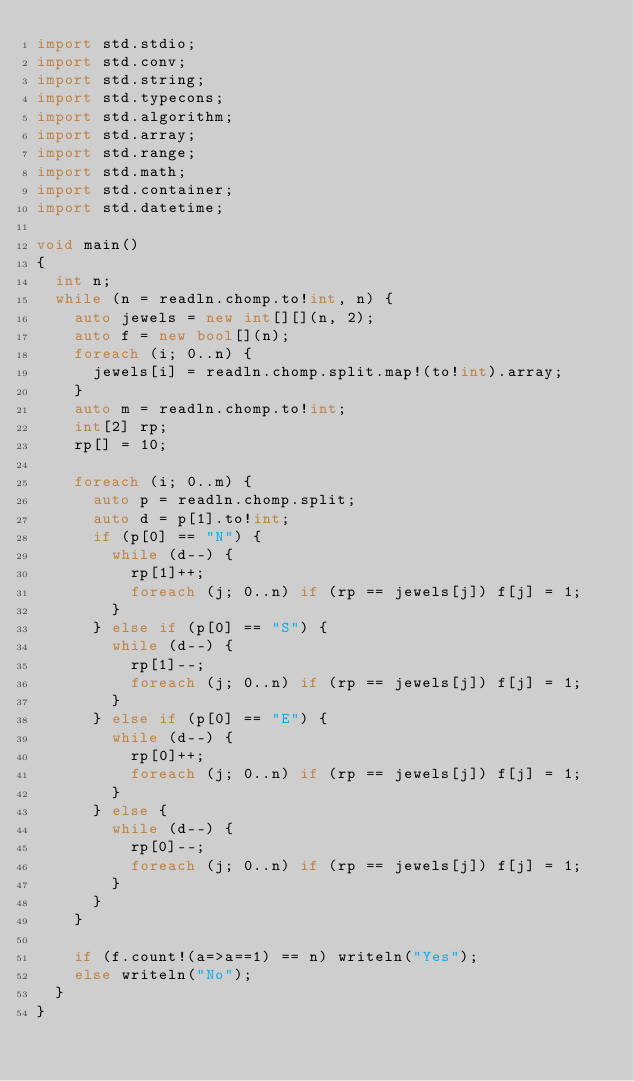<code> <loc_0><loc_0><loc_500><loc_500><_D_>import std.stdio;
import std.conv;
import std.string;
import std.typecons;
import std.algorithm;
import std.array;
import std.range;
import std.math;
import std.container;
import std.datetime;

void main()
{
	int n;
	while (n = readln.chomp.to!int, n) {
		auto jewels = new int[][](n, 2);
		auto f = new bool[](n);
		foreach (i; 0..n) {
			jewels[i] = readln.chomp.split.map!(to!int).array;
		}
		auto m = readln.chomp.to!int;
		int[2] rp;
		rp[] = 10;

		foreach (i; 0..m) {
			auto p = readln.chomp.split;
			auto d = p[1].to!int;
			if (p[0] == "N") {
				while (d--) {
					rp[1]++;
					foreach (j; 0..n) if (rp == jewels[j]) f[j] = 1;
				}
			} else if (p[0] == "S") {
				while (d--) {
					rp[1]--;
					foreach (j; 0..n) if (rp == jewels[j]) f[j] = 1;
				}
			} else if (p[0] == "E") {
				while (d--) {
					rp[0]++;
					foreach (j; 0..n) if (rp == jewels[j]) f[j] = 1;
				}
			} else {
				while (d--) {
					rp[0]--;
					foreach (j; 0..n) if (rp == jewels[j]) f[j] = 1;
				}
			} 
		}

		if (f.count!(a=>a==1) == n) writeln("Yes");
		else writeln("No");
	}
}</code> 